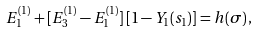Convert formula to latex. <formula><loc_0><loc_0><loc_500><loc_500>E ^ { ( 1 ) } _ { 1 } + [ E ^ { ( 1 ) } _ { 3 } - E ^ { ( 1 ) } _ { 1 } ] \, [ 1 - Y _ { 1 } ( s _ { 1 } ) ] = h ( \sigma ) \, ,</formula> 